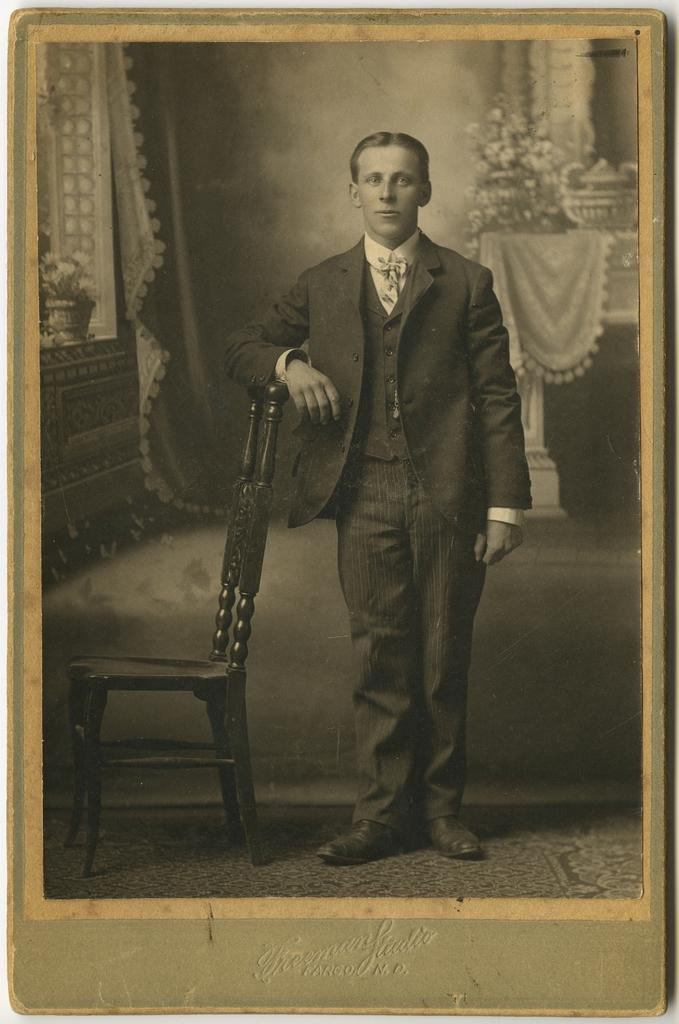What is the color scheme of the image? The image is black and white. What can be seen in the image besides the color scheme? There is a person standing in the image. Where is the person standing in relation to other objects? The person is standing beside a chair. What other furniture is present in the image? There is a table in the image. How is the table positioned in relation to the person? The table is behind the person. What decorative item is on the table? There is a flower vase on the table. What type of work is the person doing in the image? The image does not provide any information about the person's work or activities. Can you describe the texture of the person's flesh in the image? The image is black and white, so it is not possible to describe the texture of the person's flesh. 